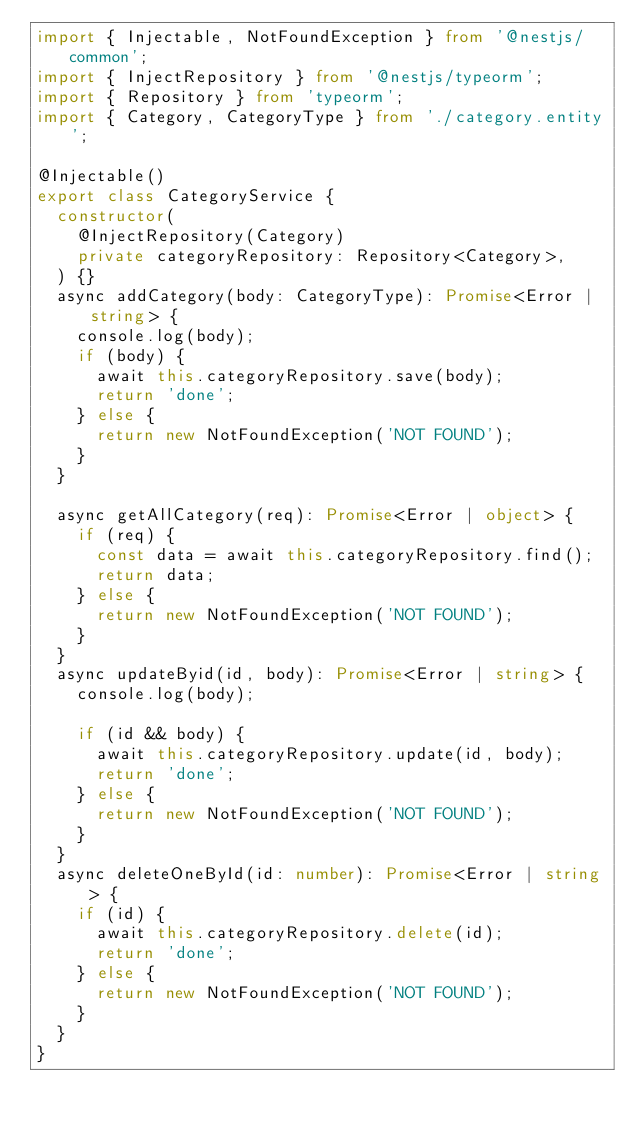<code> <loc_0><loc_0><loc_500><loc_500><_TypeScript_>import { Injectable, NotFoundException } from '@nestjs/common';
import { InjectRepository } from '@nestjs/typeorm';
import { Repository } from 'typeorm';
import { Category, CategoryType } from './category.entity';

@Injectable()
export class CategoryService {
  constructor(
    @InjectRepository(Category)
    private categoryRepository: Repository<Category>,
  ) {}
  async addCategory(body: CategoryType): Promise<Error | string> {
    console.log(body);
    if (body) {
      await this.categoryRepository.save(body);
      return 'done';
    } else {
      return new NotFoundException('NOT FOUND');
    }
  }

  async getAllCategory(req): Promise<Error | object> {
    if (req) {
      const data = await this.categoryRepository.find();
      return data;
    } else {
      return new NotFoundException('NOT FOUND');
    }
  }
  async updateByid(id, body): Promise<Error | string> {
    console.log(body);

    if (id && body) {
      await this.categoryRepository.update(id, body);
      return 'done';
    } else {
      return new NotFoundException('NOT FOUND');
    }
  }
  async deleteOneById(id: number): Promise<Error | string> {
    if (id) {
      await this.categoryRepository.delete(id);
      return 'done';
    } else {
      return new NotFoundException('NOT FOUND');
    }
  }
}
</code> 